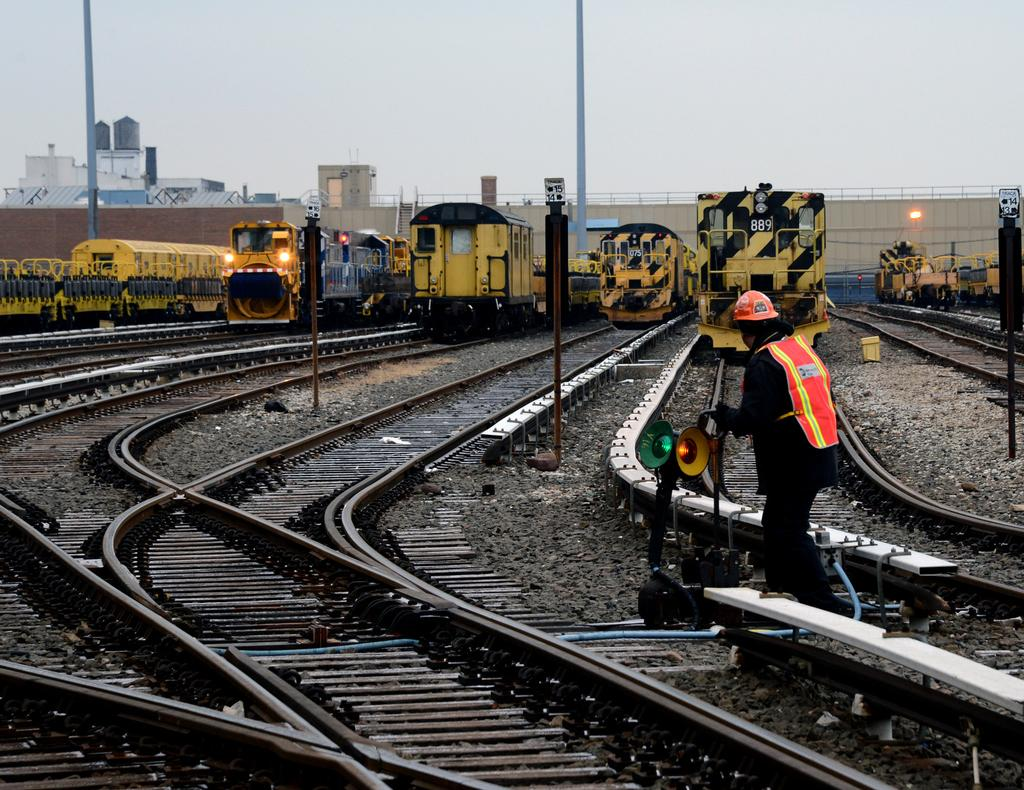What is the main subject in the image? There is a person in the image. What else can be seen in the image besides the person? There is an object, trains, train tracks, poles, buildings, a wall, a fence, and the sky visible in the image. Can you describe the setting of the image? The image features train tracks, poles, buildings, a wall, and a fence in the background, suggesting an urban or industrial setting. What is the condition of the sky in the image? The sky is visible in the background of the image. How many turkeys are visible in the image? There are no turkeys present in the image. What is the person in the image doing with the end of the train? There is no indication in the image that the person is interacting with the end of a train. 